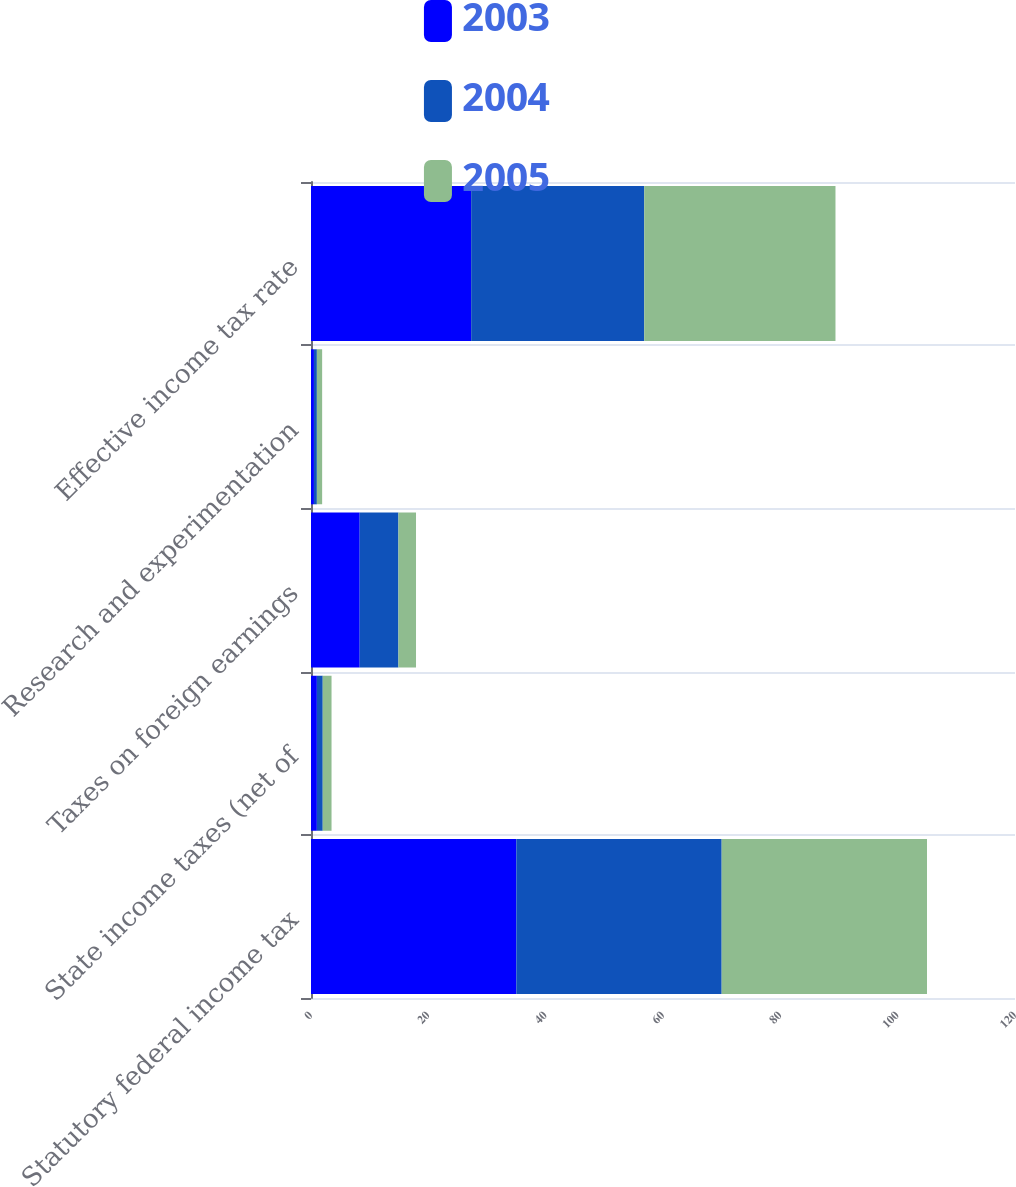<chart> <loc_0><loc_0><loc_500><loc_500><stacked_bar_chart><ecel><fcel>Statutory federal income tax<fcel>State income taxes (net of<fcel>Taxes on foreign earnings<fcel>Research and experimentation<fcel>Effective income tax rate<nl><fcel>2003<fcel>35<fcel>1<fcel>8.3<fcel>0.5<fcel>27.3<nl><fcel>2004<fcel>35<fcel>1<fcel>6.6<fcel>0.5<fcel>29.5<nl><fcel>2005<fcel>35<fcel>1.5<fcel>3<fcel>0.9<fcel>32.6<nl></chart> 